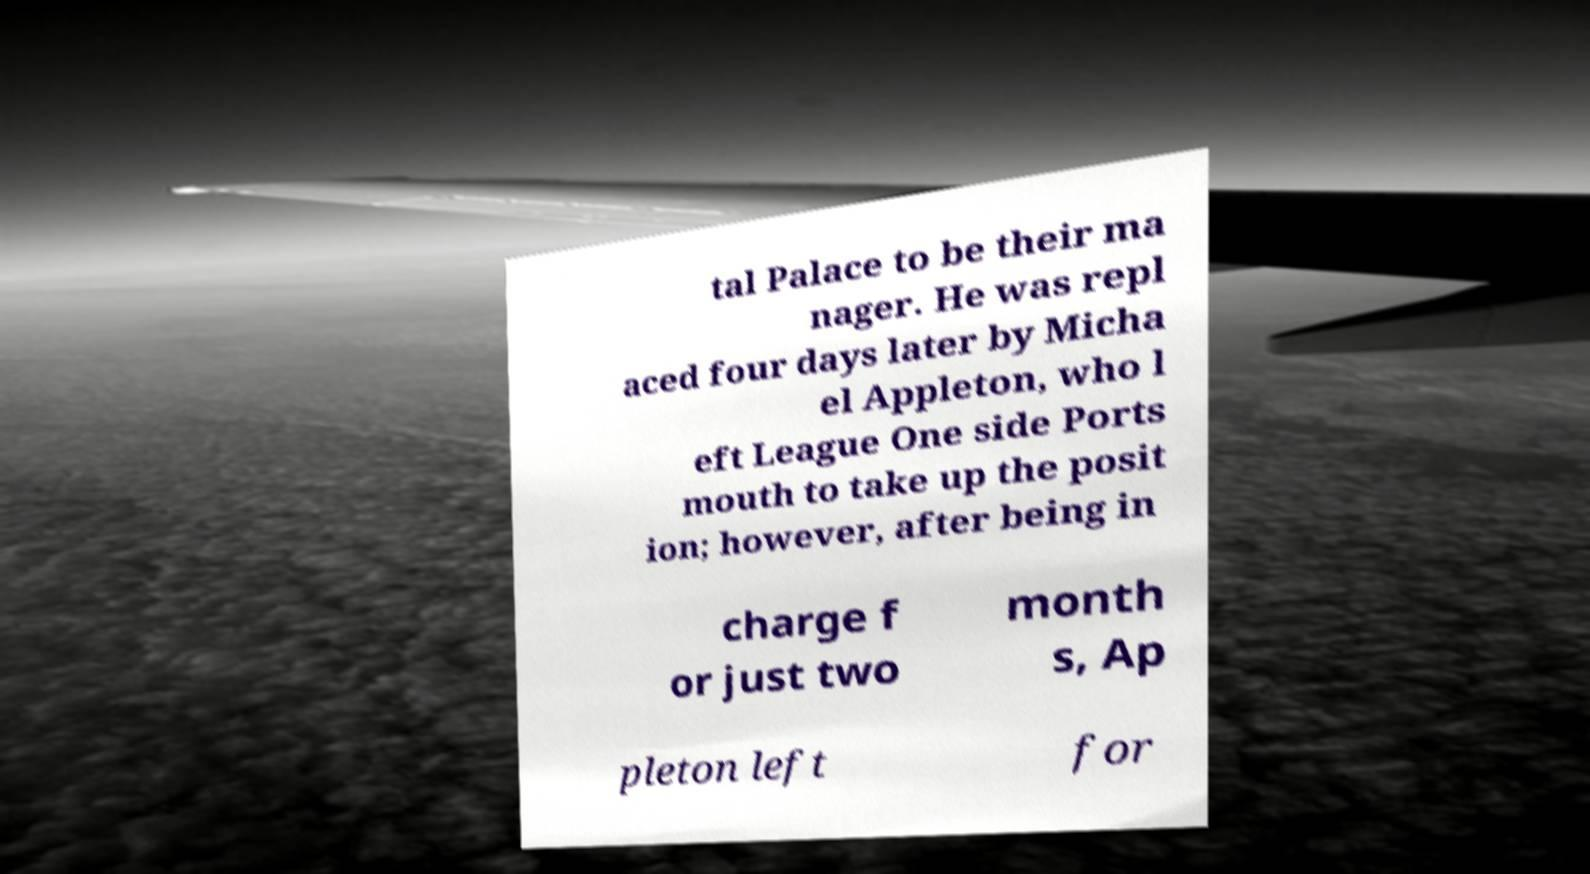I need the written content from this picture converted into text. Can you do that? tal Palace to be their ma nager. He was repl aced four days later by Micha el Appleton, who l eft League One side Ports mouth to take up the posit ion; however, after being in charge f or just two month s, Ap pleton left for 